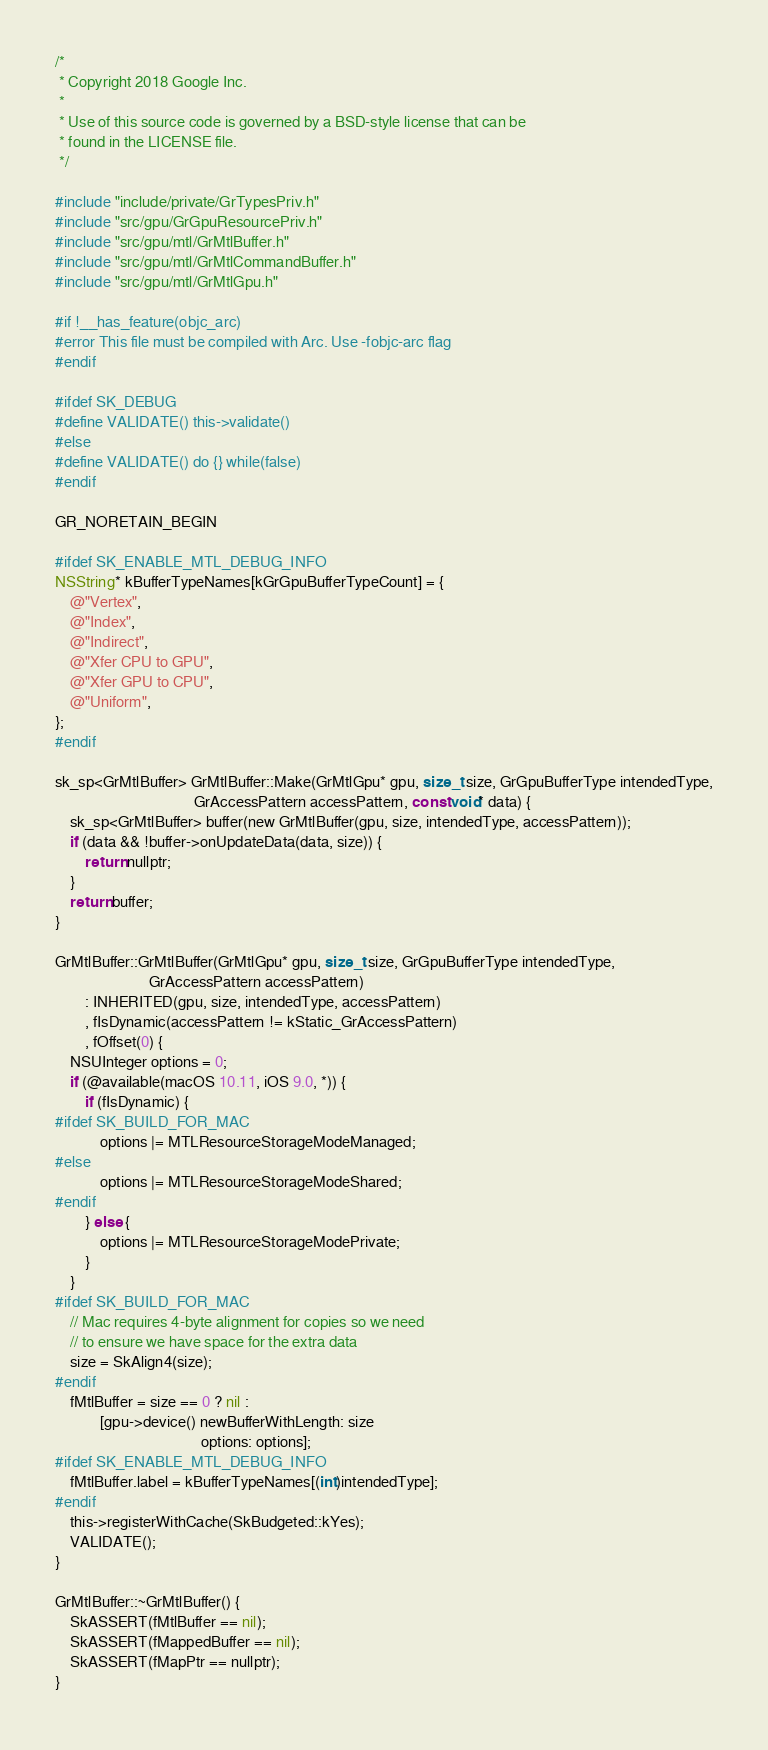<code> <loc_0><loc_0><loc_500><loc_500><_ObjectiveC_>/*
 * Copyright 2018 Google Inc.
 *
 * Use of this source code is governed by a BSD-style license that can be
 * found in the LICENSE file.
 */

#include "include/private/GrTypesPriv.h"
#include "src/gpu/GrGpuResourcePriv.h"
#include "src/gpu/mtl/GrMtlBuffer.h"
#include "src/gpu/mtl/GrMtlCommandBuffer.h"
#include "src/gpu/mtl/GrMtlGpu.h"

#if !__has_feature(objc_arc)
#error This file must be compiled with Arc. Use -fobjc-arc flag
#endif

#ifdef SK_DEBUG
#define VALIDATE() this->validate()
#else
#define VALIDATE() do {} while(false)
#endif

GR_NORETAIN_BEGIN

#ifdef SK_ENABLE_MTL_DEBUG_INFO
NSString* kBufferTypeNames[kGrGpuBufferTypeCount] = {
    @"Vertex",
    @"Index",
    @"Indirect",
    @"Xfer CPU to GPU",
    @"Xfer GPU to CPU",
    @"Uniform",
};
#endif

sk_sp<GrMtlBuffer> GrMtlBuffer::Make(GrMtlGpu* gpu, size_t size, GrGpuBufferType intendedType,
                                     GrAccessPattern accessPattern, const void* data) {
    sk_sp<GrMtlBuffer> buffer(new GrMtlBuffer(gpu, size, intendedType, accessPattern));
    if (data && !buffer->onUpdateData(data, size)) {
        return nullptr;
    }
    return buffer;
}

GrMtlBuffer::GrMtlBuffer(GrMtlGpu* gpu, size_t size, GrGpuBufferType intendedType,
                         GrAccessPattern accessPattern)
        : INHERITED(gpu, size, intendedType, accessPattern)
        , fIsDynamic(accessPattern != kStatic_GrAccessPattern)
        , fOffset(0) {
    NSUInteger options = 0;
    if (@available(macOS 10.11, iOS 9.0, *)) {
        if (fIsDynamic) {
#ifdef SK_BUILD_FOR_MAC
            options |= MTLResourceStorageModeManaged;
#else
            options |= MTLResourceStorageModeShared;
#endif
        } else {
            options |= MTLResourceStorageModePrivate;
        }
    }
#ifdef SK_BUILD_FOR_MAC
    // Mac requires 4-byte alignment for copies so we need
    // to ensure we have space for the extra data
    size = SkAlign4(size);
#endif
    fMtlBuffer = size == 0 ? nil :
            [gpu->device() newBufferWithLength: size
                                       options: options];
#ifdef SK_ENABLE_MTL_DEBUG_INFO
    fMtlBuffer.label = kBufferTypeNames[(int)intendedType];
#endif
    this->registerWithCache(SkBudgeted::kYes);
    VALIDATE();
}

GrMtlBuffer::~GrMtlBuffer() {
    SkASSERT(fMtlBuffer == nil);
    SkASSERT(fMappedBuffer == nil);
    SkASSERT(fMapPtr == nullptr);
}
</code> 